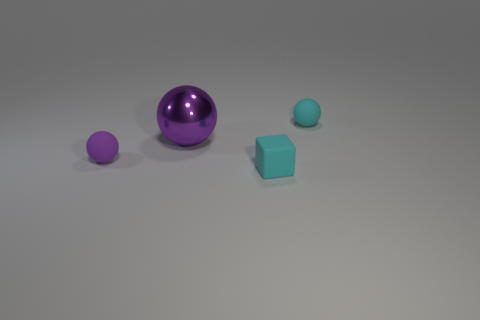Subtract all small cyan spheres. How many spheres are left? 2 Subtract all cyan spheres. How many spheres are left? 2 Subtract all balls. How many objects are left? 1 Subtract all blue blocks. How many purple spheres are left? 2 Subtract all large purple balls. Subtract all rubber balls. How many objects are left? 1 Add 2 cyan cubes. How many cyan cubes are left? 3 Add 1 tiny purple rubber things. How many tiny purple rubber things exist? 2 Add 3 purple cylinders. How many objects exist? 7 Subtract 1 purple spheres. How many objects are left? 3 Subtract 1 balls. How many balls are left? 2 